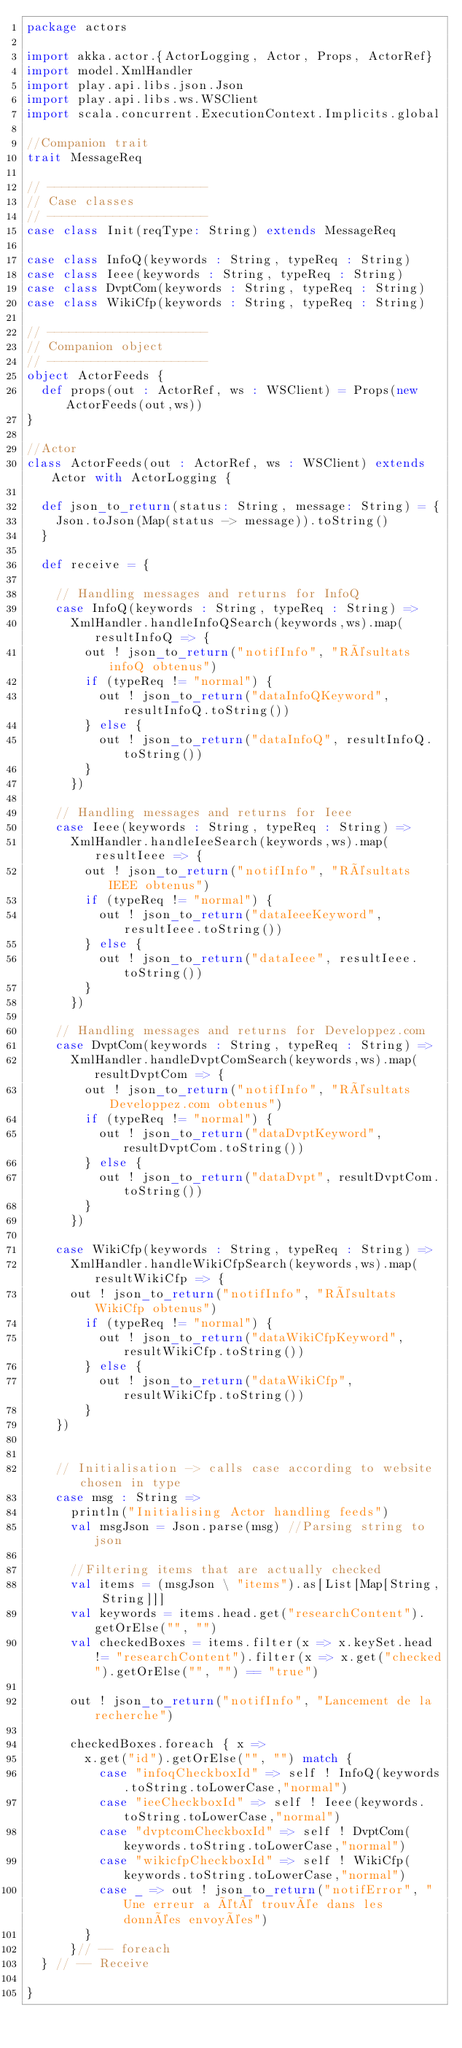<code> <loc_0><loc_0><loc_500><loc_500><_Scala_>package actors

import akka.actor.{ActorLogging, Actor, Props, ActorRef}
import model.XmlHandler
import play.api.libs.json.Json
import play.api.libs.ws.WSClient
import scala.concurrent.ExecutionContext.Implicits.global

//Companion trait
trait MessageReq

// ----------------------
// Case classes
// ----------------------
case class Init(reqType: String) extends MessageReq

case class InfoQ(keywords : String, typeReq : String)
case class Ieee(keywords : String, typeReq : String)
case class DvptCom(keywords : String, typeReq : String)
case class WikiCfp(keywords : String, typeReq : String)

// ----------------------
// Companion object
// ----------------------
object ActorFeeds {
  def props(out : ActorRef, ws : WSClient) = Props(new ActorFeeds(out,ws))
}

//Actor
class ActorFeeds(out : ActorRef, ws : WSClient) extends Actor with ActorLogging {

  def json_to_return(status: String, message: String) = {
    Json.toJson(Map(status -> message)).toString()
  }

  def receive = {

    // Handling messages and returns for InfoQ
    case InfoQ(keywords : String, typeReq : String) =>
      XmlHandler.handleInfoQSearch(keywords,ws).map(resultInfoQ => {
        out ! json_to_return("notifInfo", "Résultats infoQ obtenus")
        if (typeReq != "normal") {
          out ! json_to_return("dataInfoQKeyword", resultInfoQ.toString())
        } else {
          out ! json_to_return("dataInfoQ", resultInfoQ.toString())
        }
      })

    // Handling messages and returns for Ieee
    case Ieee(keywords : String, typeReq : String) =>
      XmlHandler.handleIeeSearch(keywords,ws).map(resultIeee => {
        out ! json_to_return("notifInfo", "Résultats IEEE obtenus")
        if (typeReq != "normal") {
          out ! json_to_return("dataIeeeKeyword", resultIeee.toString())
        } else {
          out ! json_to_return("dataIeee", resultIeee.toString())
        }
      })

    // Handling messages and returns for Developpez.com
    case DvptCom(keywords : String, typeReq : String) =>
      XmlHandler.handleDvptComSearch(keywords,ws).map(resultDvptCom => {
        out ! json_to_return("notifInfo", "Résultats Developpez.com obtenus")
        if (typeReq != "normal") {
          out ! json_to_return("dataDvptKeyword", resultDvptCom.toString())
        } else {
          out ! json_to_return("dataDvpt", resultDvptCom.toString())
        }
      })

    case WikiCfp(keywords : String, typeReq : String) =>
      XmlHandler.handleWikiCfpSearch(keywords,ws).map(resultWikiCfp => {
      out ! json_to_return("notifInfo", "Résultats WikiCfp obtenus")
        if (typeReq != "normal") {
          out ! json_to_return("dataWikiCfpKeyword", resultWikiCfp.toString())
        } else {
          out ! json_to_return("dataWikiCfp", resultWikiCfp.toString())
        }
    })


    // Initialisation -> calls case according to website chosen in type
    case msg : String =>
      println("Initialising Actor handling feeds")
      val msgJson = Json.parse(msg) //Parsing string to json

      //Filtering items that are actually checked
      val items = (msgJson \ "items").as[List[Map[String, String]]]
      val keywords = items.head.get("researchContent").getOrElse("", "")
      val checkedBoxes = items.filter(x => x.keySet.head != "researchContent").filter(x => x.get("checked").getOrElse("", "") == "true")

      out ! json_to_return("notifInfo", "Lancement de la recherche")

      checkedBoxes.foreach { x =>
        x.get("id").getOrElse("", "") match {
          case "infoqCheckboxId" => self ! InfoQ(keywords.toString.toLowerCase,"normal")
          case "ieeCheckboxId" => self ! Ieee(keywords.toString.toLowerCase,"normal")
          case "dvptcomCheckboxId" => self ! DvptCom(keywords.toString.toLowerCase,"normal")
          case "wikicfpCheckboxId" => self ! WikiCfp(keywords.toString.toLowerCase,"normal")
          case _ => out ! json_to_return("notifError", "Une erreur a été trouvée dans les données envoyées")
        }
      }// -- foreach
  } // -- Receive

}
</code> 